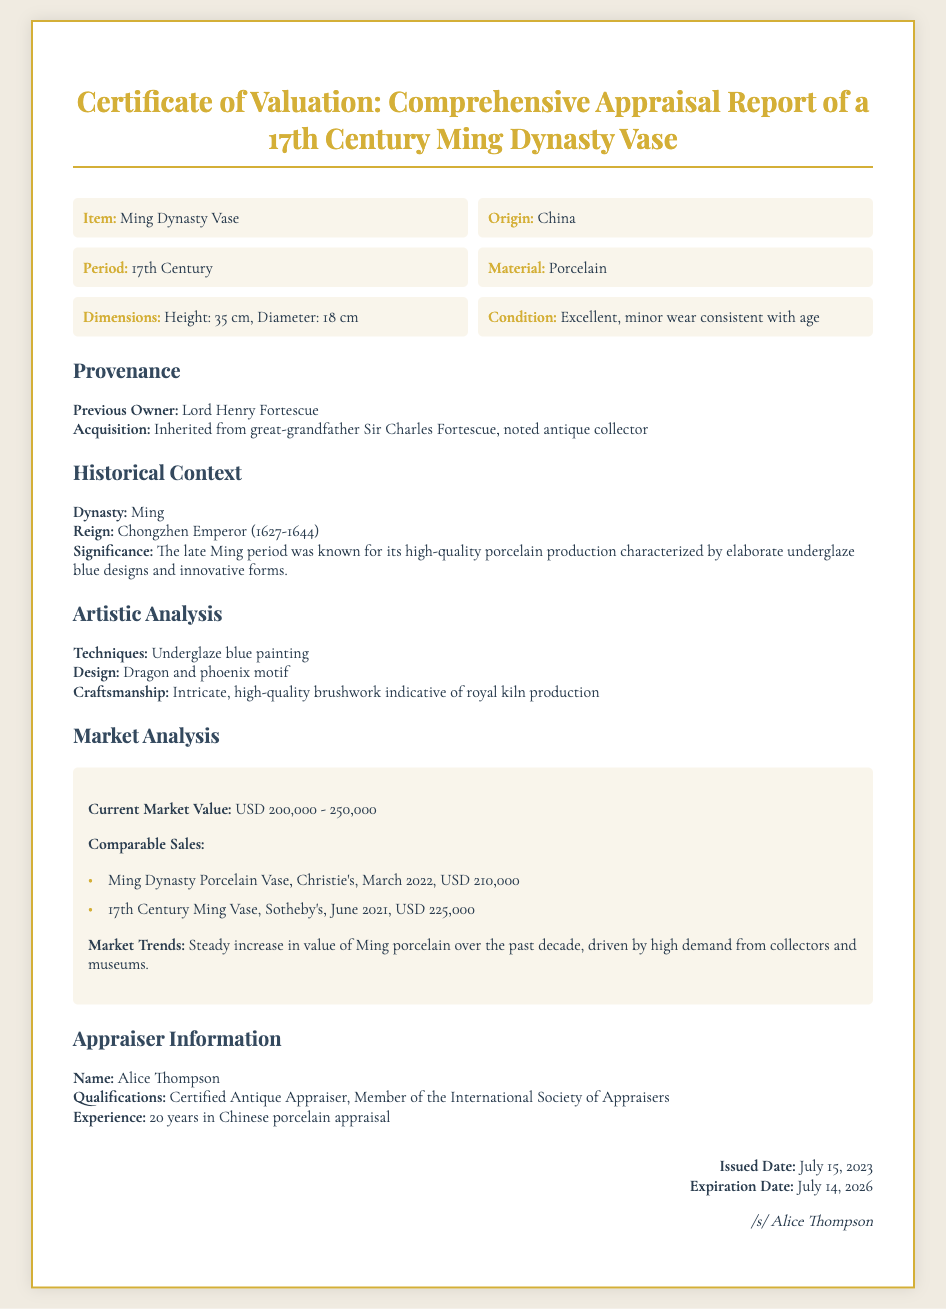what is the current market value range of the vase? The document states the current market value as USD 200,000 - 250,000.
Answer: USD 200,000 - 250,000 who was the previous owner of the vase? The previous owner mentioned in the document is Lord Henry Fortescue.
Answer: Lord Henry Fortescue what is the height of the vase? The dimensions provided in the document state the height as 35 cm.
Answer: 35 cm what motif is featured on the vase? The artistic analysis section describes the design motif as dragon and phoenix.
Answer: dragon and phoenix who is the certified appraiser for the vase? The appraiser's name listed in the document is Alice Thompson.
Answer: Alice Thompson what is the significance of the vase's production period? The document notes that the late Ming period was known for high-quality porcelain production.
Answer: high-quality porcelain production when was the certificate issued? The issued date of the certificate is July 15, 2023.
Answer: July 15, 2023 how many years of experience does Alice Thompson have in appraisal? The document mentions she has 20 years of experience in Chinese porcelain appraisal.
Answer: 20 years what techniques were used in the vase's creation? The artistic analysis section states that underglaze blue painting was used.
Answer: Underglaze blue painting 